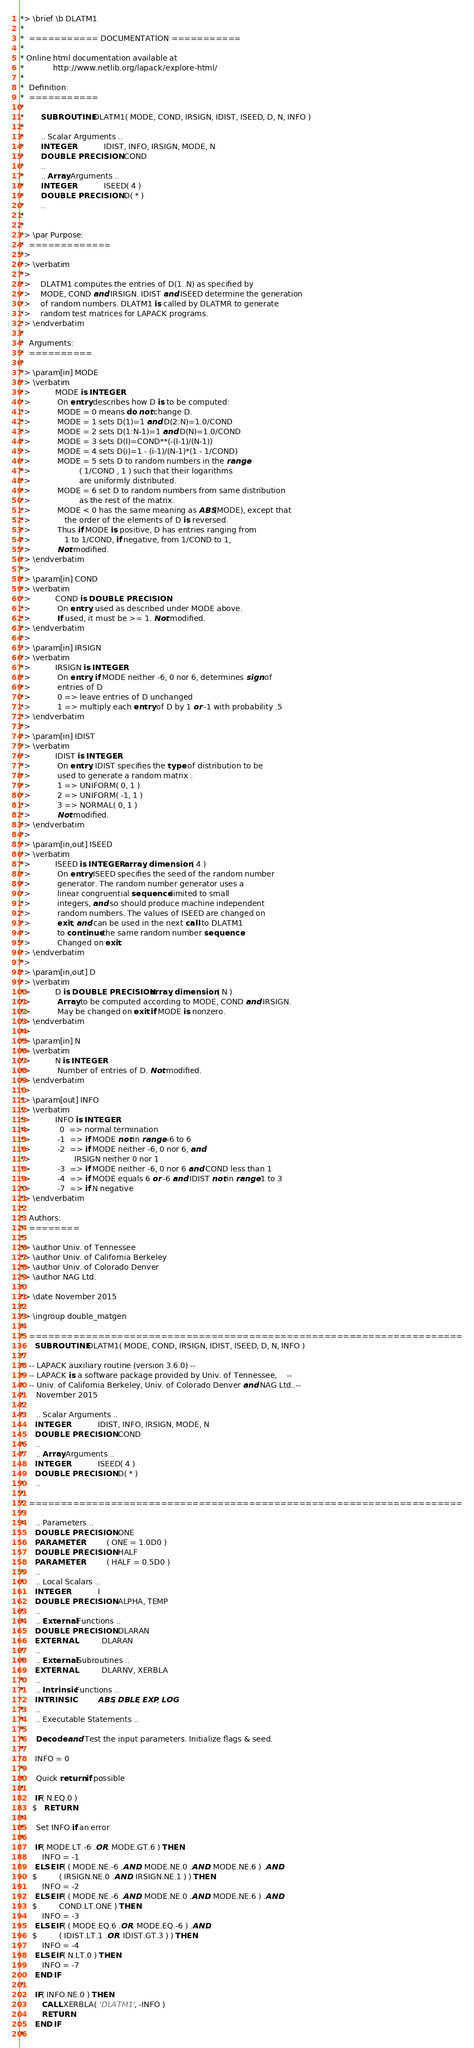Convert code to text. <code><loc_0><loc_0><loc_500><loc_500><_FORTRAN_>*> \brief \b DLATM1
*
*  =========== DOCUMENTATION ===========
*
* Online html documentation available at 
*            http://www.netlib.org/lapack/explore-html/ 
*
*  Definition:
*  ===========
*
*       SUBROUTINE DLATM1( MODE, COND, IRSIGN, IDIST, ISEED, D, N, INFO )
* 
*       .. Scalar Arguments ..
*       INTEGER            IDIST, INFO, IRSIGN, MODE, N
*       DOUBLE PRECISION   COND
*       ..
*       .. Array Arguments ..
*       INTEGER            ISEED( 4 )
*       DOUBLE PRECISION   D( * )
*       ..
*  
*
*> \par Purpose:
*  =============
*>
*> \verbatim
*>
*>    DLATM1 computes the entries of D(1..N) as specified by
*>    MODE, COND and IRSIGN. IDIST and ISEED determine the generation
*>    of random numbers. DLATM1 is called by DLATMR to generate
*>    random test matrices for LAPACK programs.
*> \endverbatim
*
*  Arguments:
*  ==========
*
*> \param[in] MODE
*> \verbatim
*>          MODE is INTEGER
*>           On entry describes how D is to be computed:
*>           MODE = 0 means do not change D.
*>           MODE = 1 sets D(1)=1 and D(2:N)=1.0/COND
*>           MODE = 2 sets D(1:N-1)=1 and D(N)=1.0/COND
*>           MODE = 3 sets D(I)=COND**(-(I-1)/(N-1))
*>           MODE = 4 sets D(i)=1 - (i-1)/(N-1)*(1 - 1/COND)
*>           MODE = 5 sets D to random numbers in the range
*>                    ( 1/COND , 1 ) such that their logarithms
*>                    are uniformly distributed.
*>           MODE = 6 set D to random numbers from same distribution
*>                    as the rest of the matrix.
*>           MODE < 0 has the same meaning as ABS(MODE), except that
*>              the order of the elements of D is reversed.
*>           Thus if MODE is positive, D has entries ranging from
*>              1 to 1/COND, if negative, from 1/COND to 1,
*>           Not modified.
*> \endverbatim
*>
*> \param[in] COND
*> \verbatim
*>          COND is DOUBLE PRECISION
*>           On entry, used as described under MODE above.
*>           If used, it must be >= 1. Not modified.
*> \endverbatim
*>
*> \param[in] IRSIGN
*> \verbatim
*>          IRSIGN is INTEGER
*>           On entry, if MODE neither -6, 0 nor 6, determines sign of
*>           entries of D
*>           0 => leave entries of D unchanged
*>           1 => multiply each entry of D by 1 or -1 with probability .5
*> \endverbatim
*>
*> \param[in] IDIST
*> \verbatim
*>          IDIST is INTEGER
*>           On entry, IDIST specifies the type of distribution to be
*>           used to generate a random matrix .
*>           1 => UNIFORM( 0, 1 )
*>           2 => UNIFORM( -1, 1 )
*>           3 => NORMAL( 0, 1 )
*>           Not modified.
*> \endverbatim
*>
*> \param[in,out] ISEED
*> \verbatim
*>          ISEED is INTEGER array, dimension ( 4 )
*>           On entry ISEED specifies the seed of the random number
*>           generator. The random number generator uses a
*>           linear congruential sequence limited to small
*>           integers, and so should produce machine independent
*>           random numbers. The values of ISEED are changed on
*>           exit, and can be used in the next call to DLATM1
*>           to continue the same random number sequence.
*>           Changed on exit.
*> \endverbatim
*>
*> \param[in,out] D
*> \verbatim
*>          D is DOUBLE PRECISION array, dimension ( N )
*>           Array to be computed according to MODE, COND and IRSIGN.
*>           May be changed on exit if MODE is nonzero.
*> \endverbatim
*>
*> \param[in] N
*> \verbatim
*>          N is INTEGER
*>           Number of entries of D. Not modified.
*> \endverbatim
*>
*> \param[out] INFO
*> \verbatim
*>          INFO is INTEGER
*>            0  => normal termination
*>           -1  => if MODE not in range -6 to 6
*>           -2  => if MODE neither -6, 0 nor 6, and
*>                  IRSIGN neither 0 nor 1
*>           -3  => if MODE neither -6, 0 nor 6 and COND less than 1
*>           -4  => if MODE equals 6 or -6 and IDIST not in range 1 to 3
*>           -7  => if N negative
*> \endverbatim
*
*  Authors:
*  ========
*
*> \author Univ. of Tennessee 
*> \author Univ. of California Berkeley 
*> \author Univ. of Colorado Denver 
*> \author NAG Ltd. 
*
*> \date November 2015
*
*> \ingroup double_matgen
*
*  =====================================================================
      SUBROUTINE DLATM1( MODE, COND, IRSIGN, IDIST, ISEED, D, N, INFO )
*
*  -- LAPACK auxiliary routine (version 3.6.0) --
*  -- LAPACK is a software package provided by Univ. of Tennessee,    --
*  -- Univ. of California Berkeley, Univ. of Colorado Denver and NAG Ltd..--
*     November 2015
*
*     .. Scalar Arguments ..
      INTEGER            IDIST, INFO, IRSIGN, MODE, N
      DOUBLE PRECISION   COND
*     ..
*     .. Array Arguments ..
      INTEGER            ISEED( 4 )
      DOUBLE PRECISION   D( * )
*     ..
*
*  =====================================================================
*
*     .. Parameters ..
      DOUBLE PRECISION   ONE
      PARAMETER          ( ONE = 1.0D0 )
      DOUBLE PRECISION   HALF
      PARAMETER          ( HALF = 0.5D0 )
*     ..
*     .. Local Scalars ..
      INTEGER            I
      DOUBLE PRECISION   ALPHA, TEMP
*     ..
*     .. External Functions ..
      DOUBLE PRECISION   DLARAN
      EXTERNAL           DLARAN
*     ..
*     .. External Subroutines ..
      EXTERNAL           DLARNV, XERBLA
*     ..
*     .. Intrinsic Functions ..
      INTRINSIC          ABS, DBLE, EXP, LOG
*     ..
*     .. Executable Statements ..
*
*     Decode and Test the input parameters. Initialize flags & seed.
*
      INFO = 0
*
*     Quick return if possible
*
      IF( N.EQ.0 )
     $   RETURN
*
*     Set INFO if an error
*
      IF( MODE.LT.-6 .OR. MODE.GT.6 ) THEN
         INFO = -1
      ELSE IF( ( MODE.NE.-6 .AND. MODE.NE.0 .AND. MODE.NE.6 ) .AND.
     $         ( IRSIGN.NE.0 .AND. IRSIGN.NE.1 ) ) THEN
         INFO = -2
      ELSE IF( ( MODE.NE.-6 .AND. MODE.NE.0 .AND. MODE.NE.6 ) .AND.
     $         COND.LT.ONE ) THEN
         INFO = -3
      ELSE IF( ( MODE.EQ.6 .OR. MODE.EQ.-6 ) .AND.
     $         ( IDIST.LT.1 .OR. IDIST.GT.3 ) ) THEN
         INFO = -4
      ELSE IF( N.LT.0 ) THEN
         INFO = -7
      END IF
*
      IF( INFO.NE.0 ) THEN
         CALL XERBLA( 'DLATM1', -INFO )
         RETURN
      END IF
*</code> 